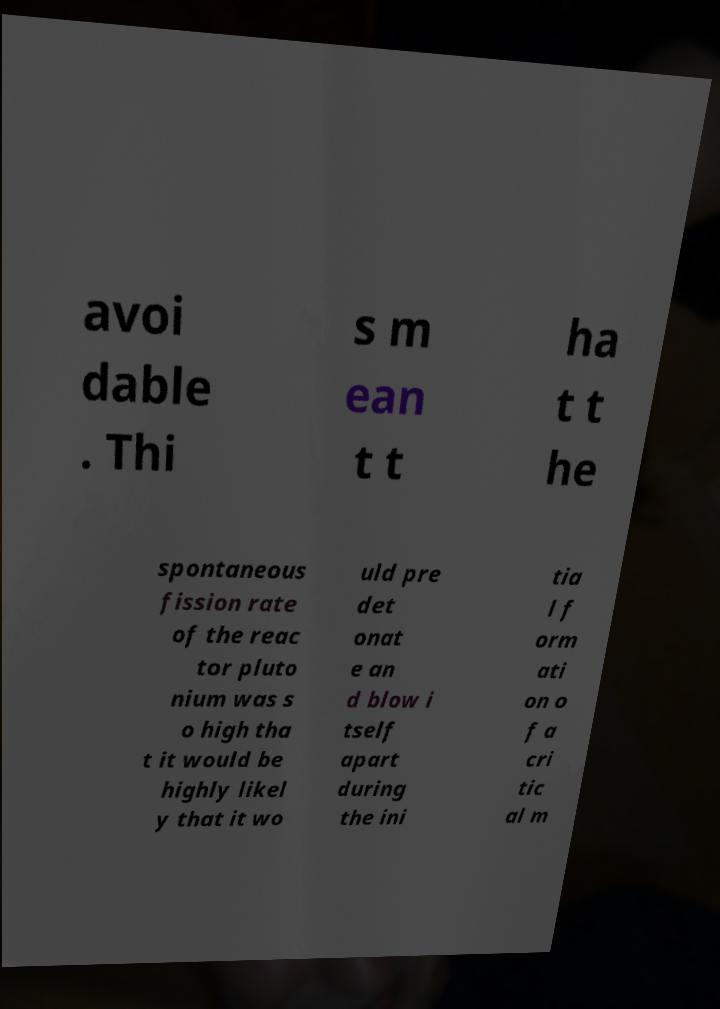I need the written content from this picture converted into text. Can you do that? avoi dable . Thi s m ean t t ha t t he spontaneous fission rate of the reac tor pluto nium was s o high tha t it would be highly likel y that it wo uld pre det onat e an d blow i tself apart during the ini tia l f orm ati on o f a cri tic al m 